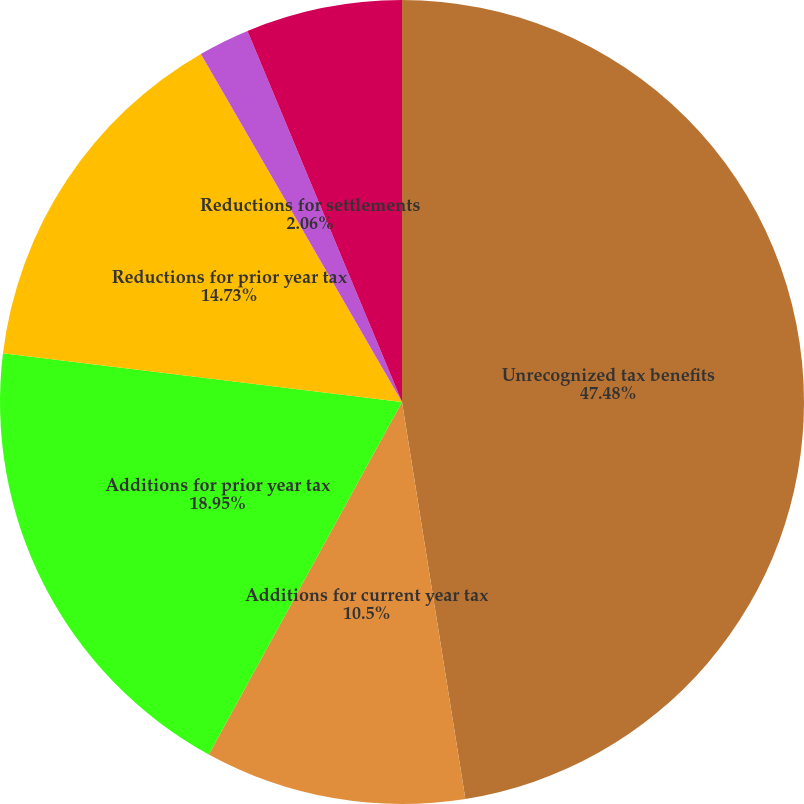Convert chart to OTSL. <chart><loc_0><loc_0><loc_500><loc_500><pie_chart><fcel>Unrecognized tax benefits<fcel>Additions for current year tax<fcel>Additions for prior year tax<fcel>Reductions for prior year tax<fcel>Reductions for settlements<fcel>Reductions for expiration of<nl><fcel>47.48%<fcel>10.5%<fcel>18.95%<fcel>14.73%<fcel>2.06%<fcel>6.28%<nl></chart> 